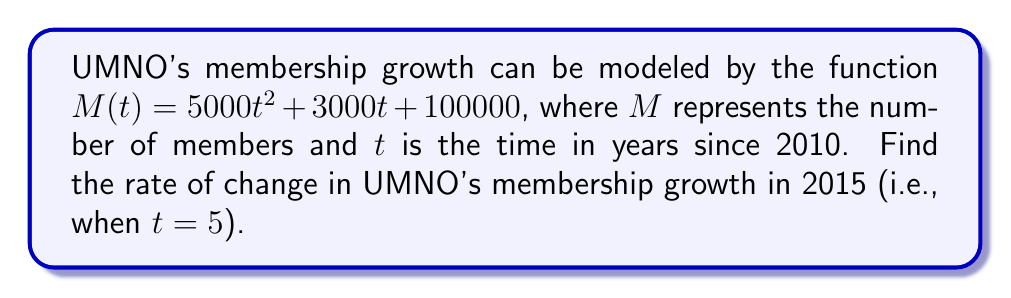Teach me how to tackle this problem. To find the rate of change in UMNO's membership growth, we need to calculate the derivative of the given function and evaluate it at $t = 5$.

Step 1: Find the derivative of $M(t)$.
$$\frac{d}{dt}M(t) = \frac{d}{dt}(5000t^2 + 3000t + 100000)$$
$$M'(t) = 10000t + 3000$$

Step 2: Evaluate the derivative at $t = 5$.
$$M'(5) = 10000(5) + 3000$$
$$M'(5) = 50000 + 3000$$
$$M'(5) = 53000$$

The rate of change in 2015 (when $t = 5$) is 53,000 members per year.
Answer: 53,000 members/year 